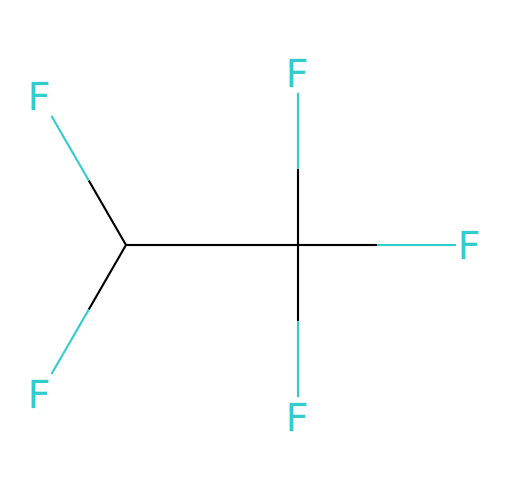What type of compound is represented by this SMILES? This SMILES represents a fluorinated compound because it contains multiple fluorine substituents bonded to a carbon backbone.
Answer: fluorinated compound How many carbon atoms are present in the structure? By analyzing the SMILES, we see there are four carbon atoms forming the backbone of the compound.
Answer: four What is the total number of fluorine atoms in the chemical? In the given SMILES, there are six fluorine atoms attached to the carbon atoms, as indicated by the multiple occurrences of 'F'.
Answer: six Does this chemical have any functional groups? The structure lacks distinctive functional groups like alcohols or carboxylic acids; it primarily consists of carbon-fluorine bonds.
Answer: no What property do these fluorinated compounds generally have due to their structure? Fluorinated compounds like this one are known for their hydrophobic characteristics, which contribute to their waterproof properties.
Answer: hydrophobic Is this structure typically associated with surfactant behavior? While surfactants alter surface tension in solutions, this highly fluorinated structure suggests it shows repellent properties rather than traditional surfactant behavior.
Answer: no 